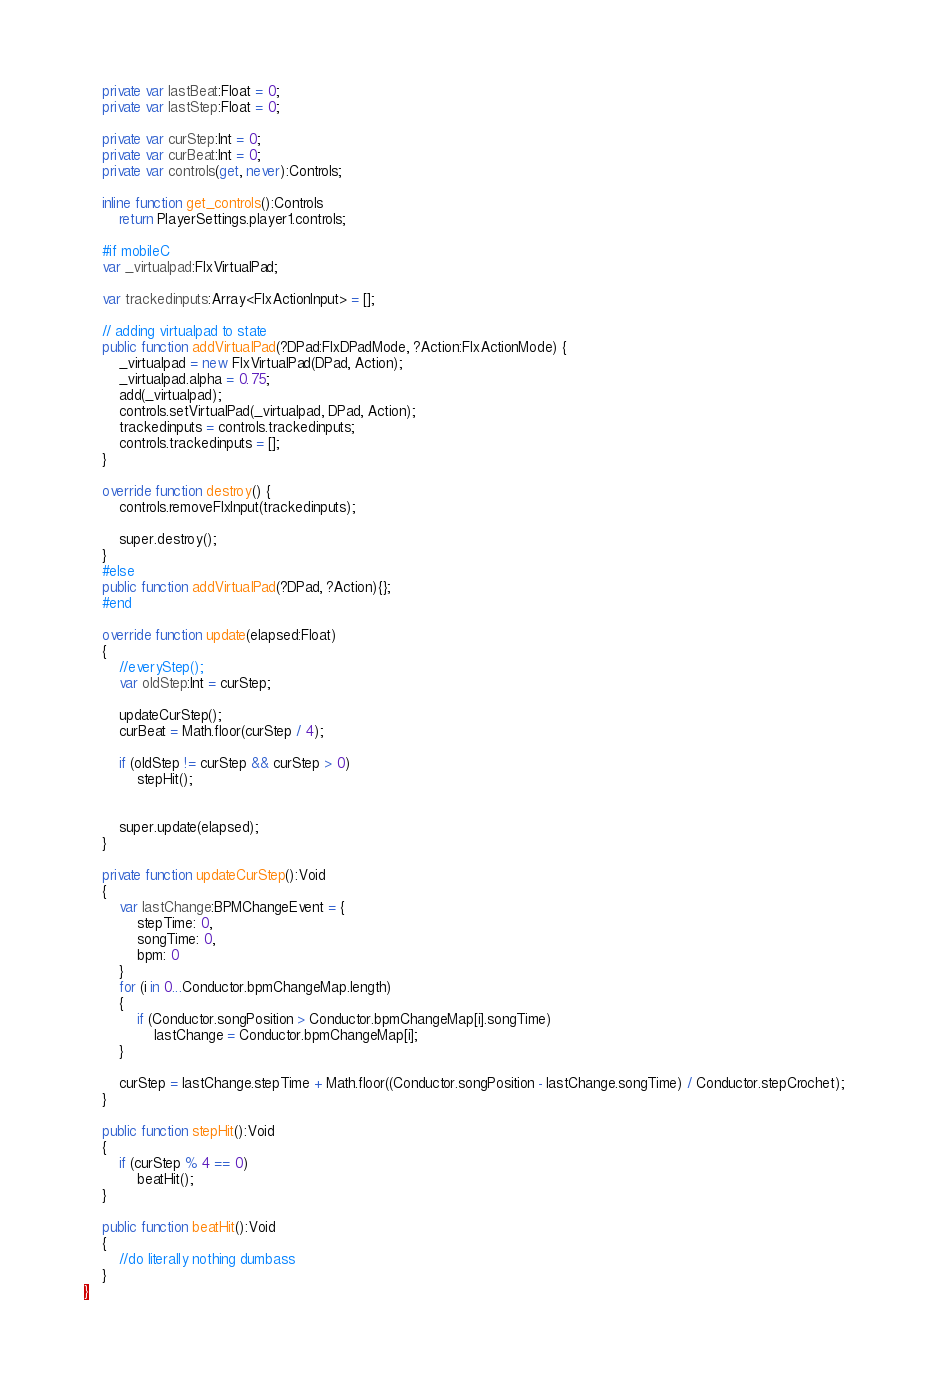Convert code to text. <code><loc_0><loc_0><loc_500><loc_500><_Haxe_>	private var lastBeat:Float = 0;
	private var lastStep:Float = 0;

	private var curStep:Int = 0;
	private var curBeat:Int = 0;
	private var controls(get, never):Controls;

	inline function get_controls():Controls
		return PlayerSettings.player1.controls;

	#if mobileC
	var _virtualpad:FlxVirtualPad;

	var trackedinputs:Array<FlxActionInput> = [];

	// adding virtualpad to state
	public function addVirtualPad(?DPad:FlxDPadMode, ?Action:FlxActionMode) {
		_virtualpad = new FlxVirtualPad(DPad, Action);
		_virtualpad.alpha = 0.75;
		add(_virtualpad);
		controls.setVirtualPad(_virtualpad, DPad, Action);
		trackedinputs = controls.trackedinputs;
		controls.trackedinputs = [];
	}
	
	override function destroy() {
		controls.removeFlxInput(trackedinputs);

		super.destroy();
	}
	#else
	public function addVirtualPad(?DPad, ?Action){};
	#end		

	override function update(elapsed:Float)
	{
		//everyStep();
		var oldStep:Int = curStep;

		updateCurStep();
		curBeat = Math.floor(curStep / 4);

		if (oldStep != curStep && curStep > 0)
			stepHit();


		super.update(elapsed);
	}

	private function updateCurStep():Void
	{
		var lastChange:BPMChangeEvent = {
			stepTime: 0,
			songTime: 0,
			bpm: 0
		}
		for (i in 0...Conductor.bpmChangeMap.length)
		{
			if (Conductor.songPosition > Conductor.bpmChangeMap[i].songTime)
				lastChange = Conductor.bpmChangeMap[i];
		}

		curStep = lastChange.stepTime + Math.floor((Conductor.songPosition - lastChange.songTime) / Conductor.stepCrochet);
	}

	public function stepHit():Void
	{
		if (curStep % 4 == 0)
			beatHit();
	}

	public function beatHit():Void
	{
		//do literally nothing dumbass
	}
}
</code> 